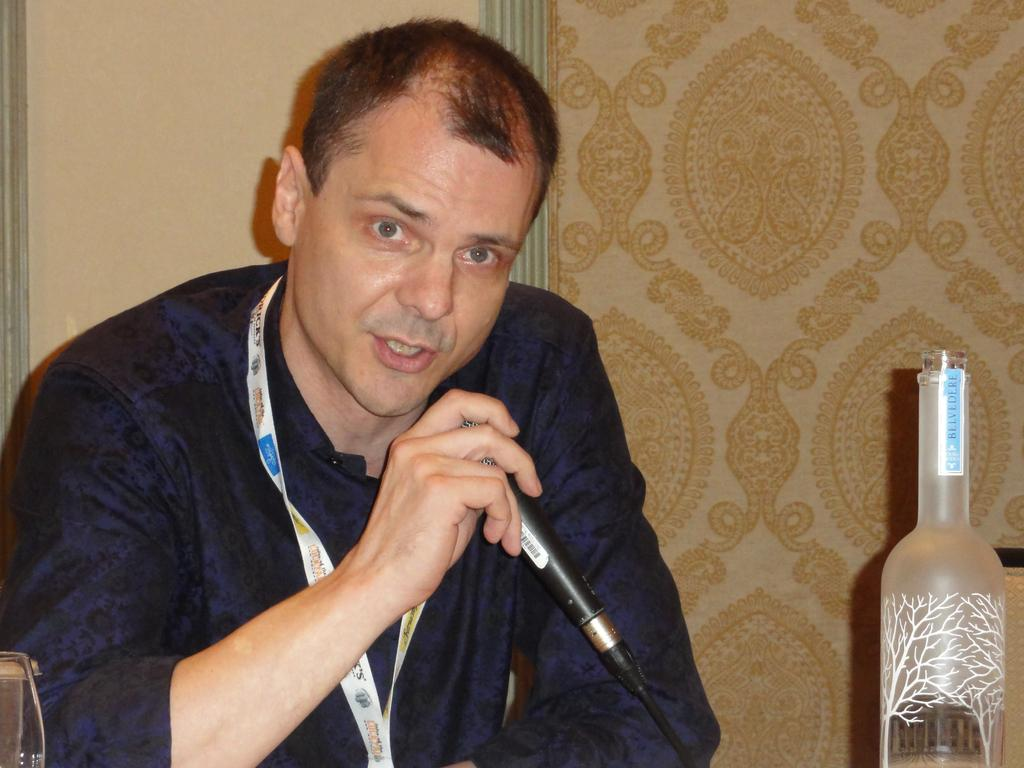What is the main subject of the image? The main subject of the image is a person. What is the person holding in his hand? The person is holding a mic in his hand. How many dolls are present in the image? There are no dolls present in the image. Is there any blood visible in the image? There is no blood visible in the image. What type of trouble is the person in the image experiencing? There is no indication of trouble in the image; the person is simply holding a mic. 